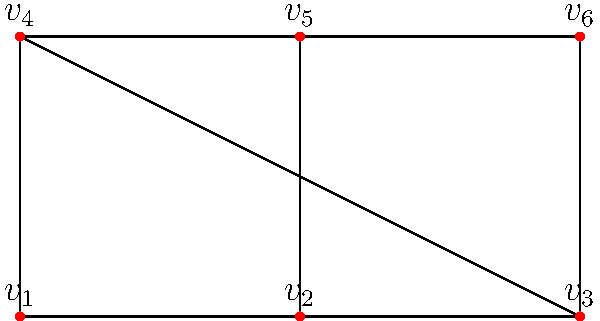Given the planar graph representing the layout of an archive storage facility, where vertices represent storage units and edges represent pathways, what is the maximum number of additional pathways (edges) that can be added while maintaining planarity? To solve this problem, we'll use Euler's formula for planar graphs and the maximum number of edges in a planar graph:

1. Count the current number of vertices (V) and edges (E):
   V = 6
   E = 8

2. Calculate the number of faces (F) using Euler's formula:
   V - E + F = 2
   6 - 8 + F = 2
   F = 4

3. Use the formula for the maximum number of edges in a planar graph:
   $E_{max} = 3V - 6$
   $E_{max} = 3(6) - 6 = 12$

4. Calculate the number of additional edges that can be added:
   Additional edges = $E_{max} - E$
   Additional edges = 12 - 8 = 4

Therefore, a maximum of 4 additional pathways can be added while maintaining planarity.
Answer: 4 